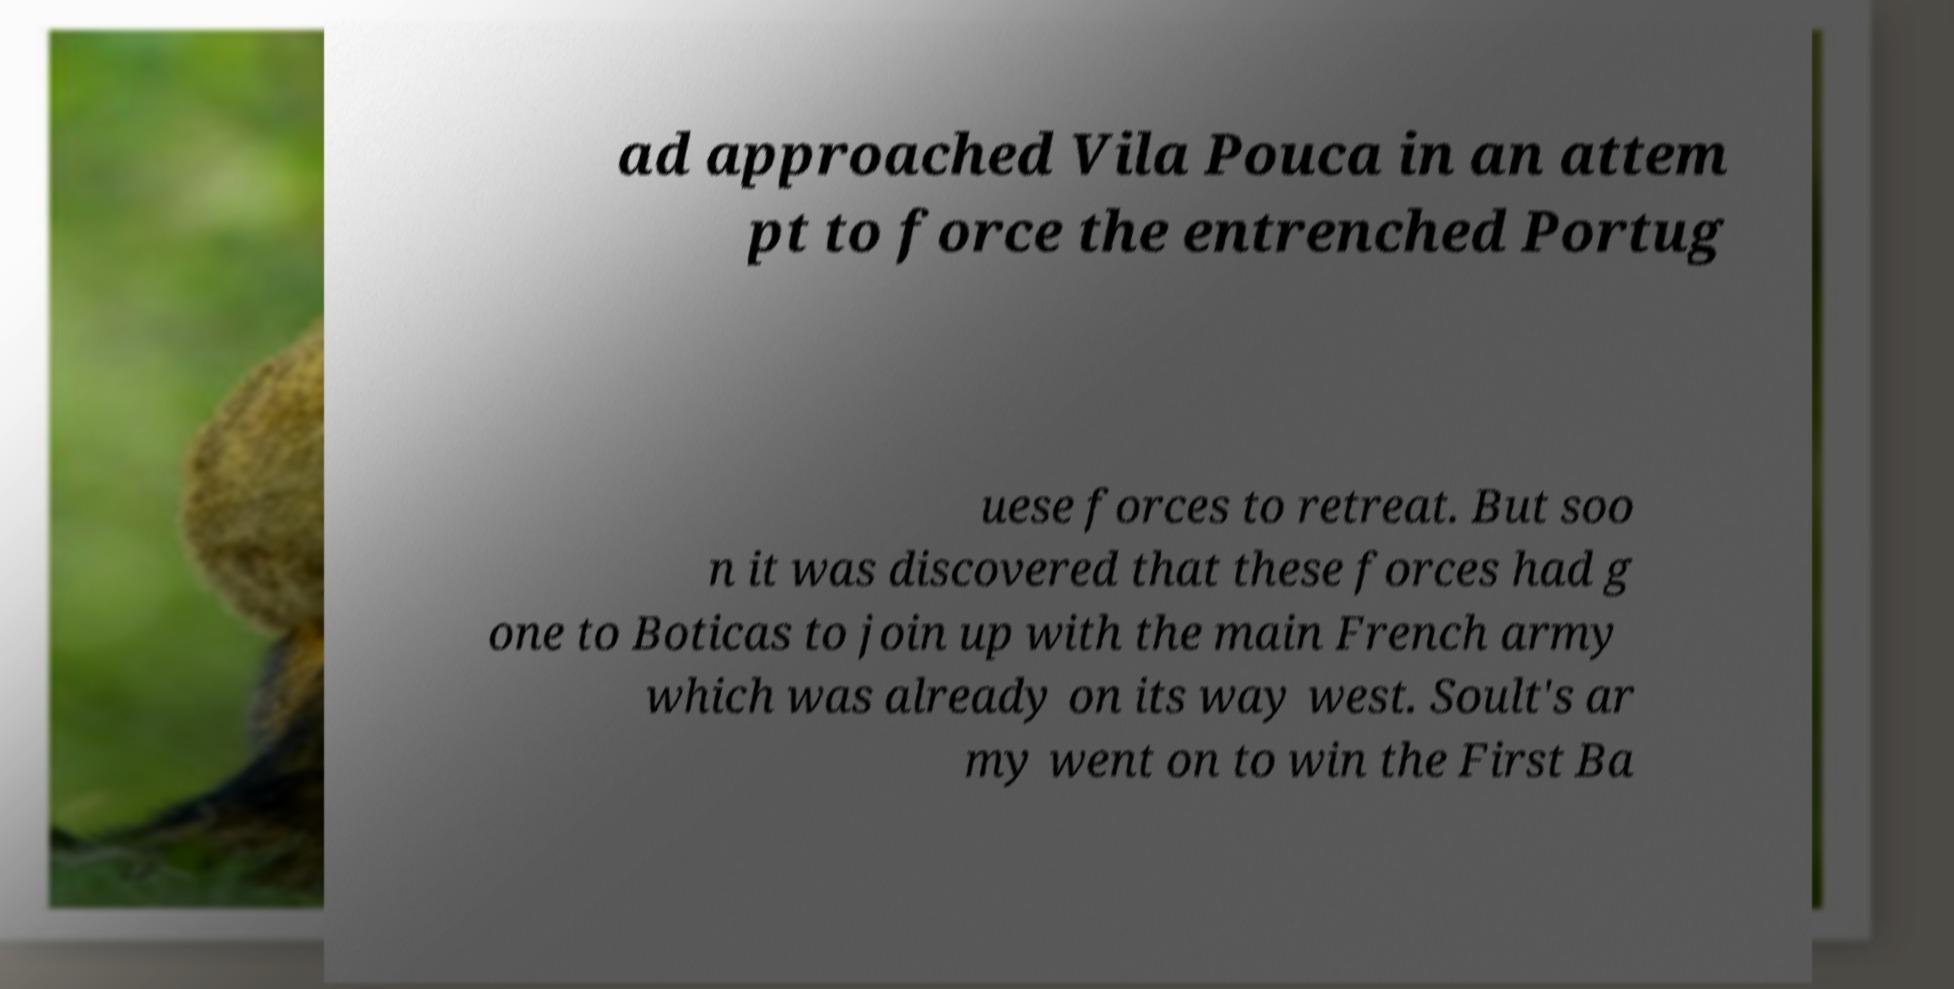Can you read and provide the text displayed in the image?This photo seems to have some interesting text. Can you extract and type it out for me? ad approached Vila Pouca in an attem pt to force the entrenched Portug uese forces to retreat. But soo n it was discovered that these forces had g one to Boticas to join up with the main French army which was already on its way west. Soult's ar my went on to win the First Ba 